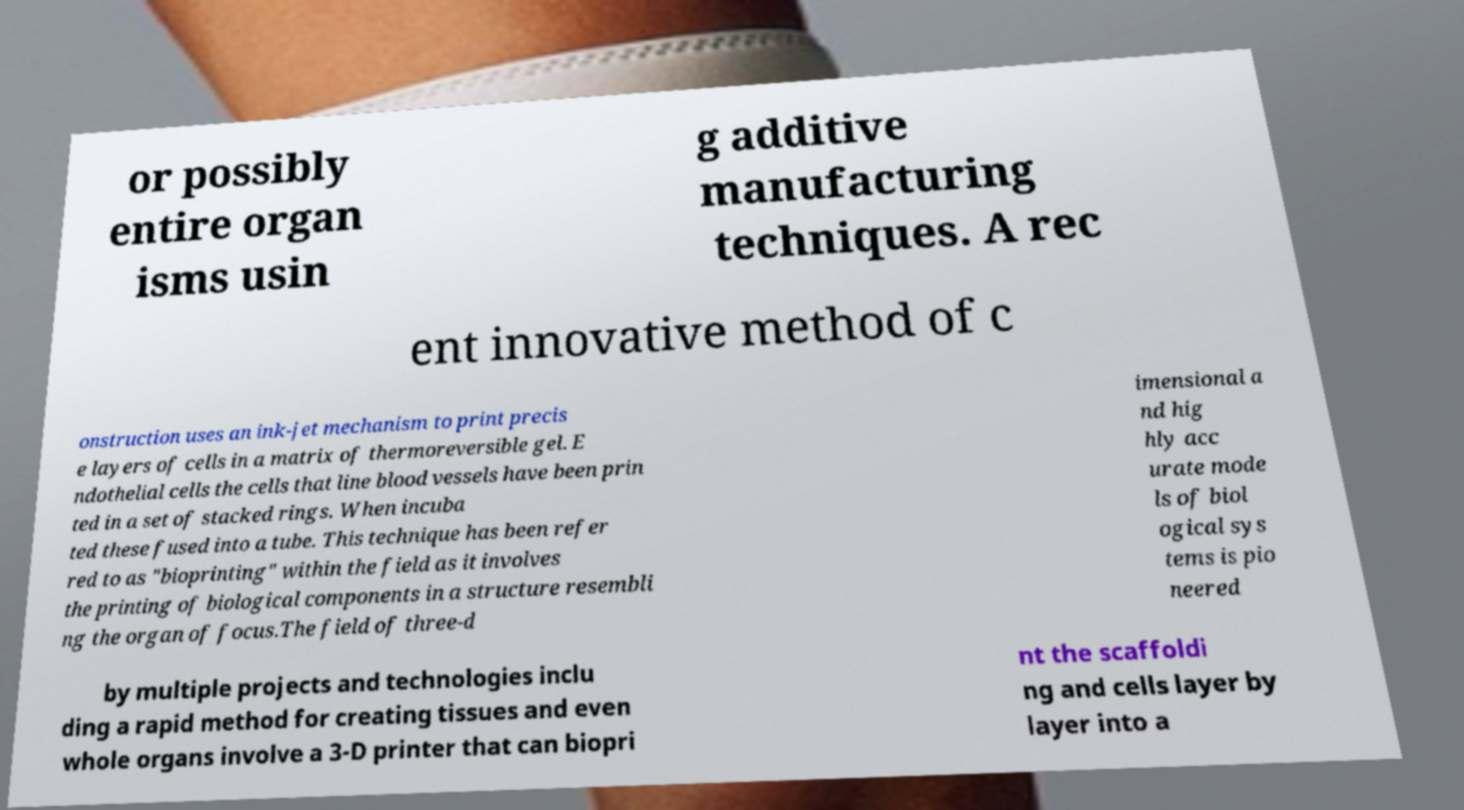Please read and relay the text visible in this image. What does it say? or possibly entire organ isms usin g additive manufacturing techniques. A rec ent innovative method of c onstruction uses an ink-jet mechanism to print precis e layers of cells in a matrix of thermoreversible gel. E ndothelial cells the cells that line blood vessels have been prin ted in a set of stacked rings. When incuba ted these fused into a tube. This technique has been refer red to as "bioprinting" within the field as it involves the printing of biological components in a structure resembli ng the organ of focus.The field of three-d imensional a nd hig hly acc urate mode ls of biol ogical sys tems is pio neered by multiple projects and technologies inclu ding a rapid method for creating tissues and even whole organs involve a 3-D printer that can biopri nt the scaffoldi ng and cells layer by layer into a 